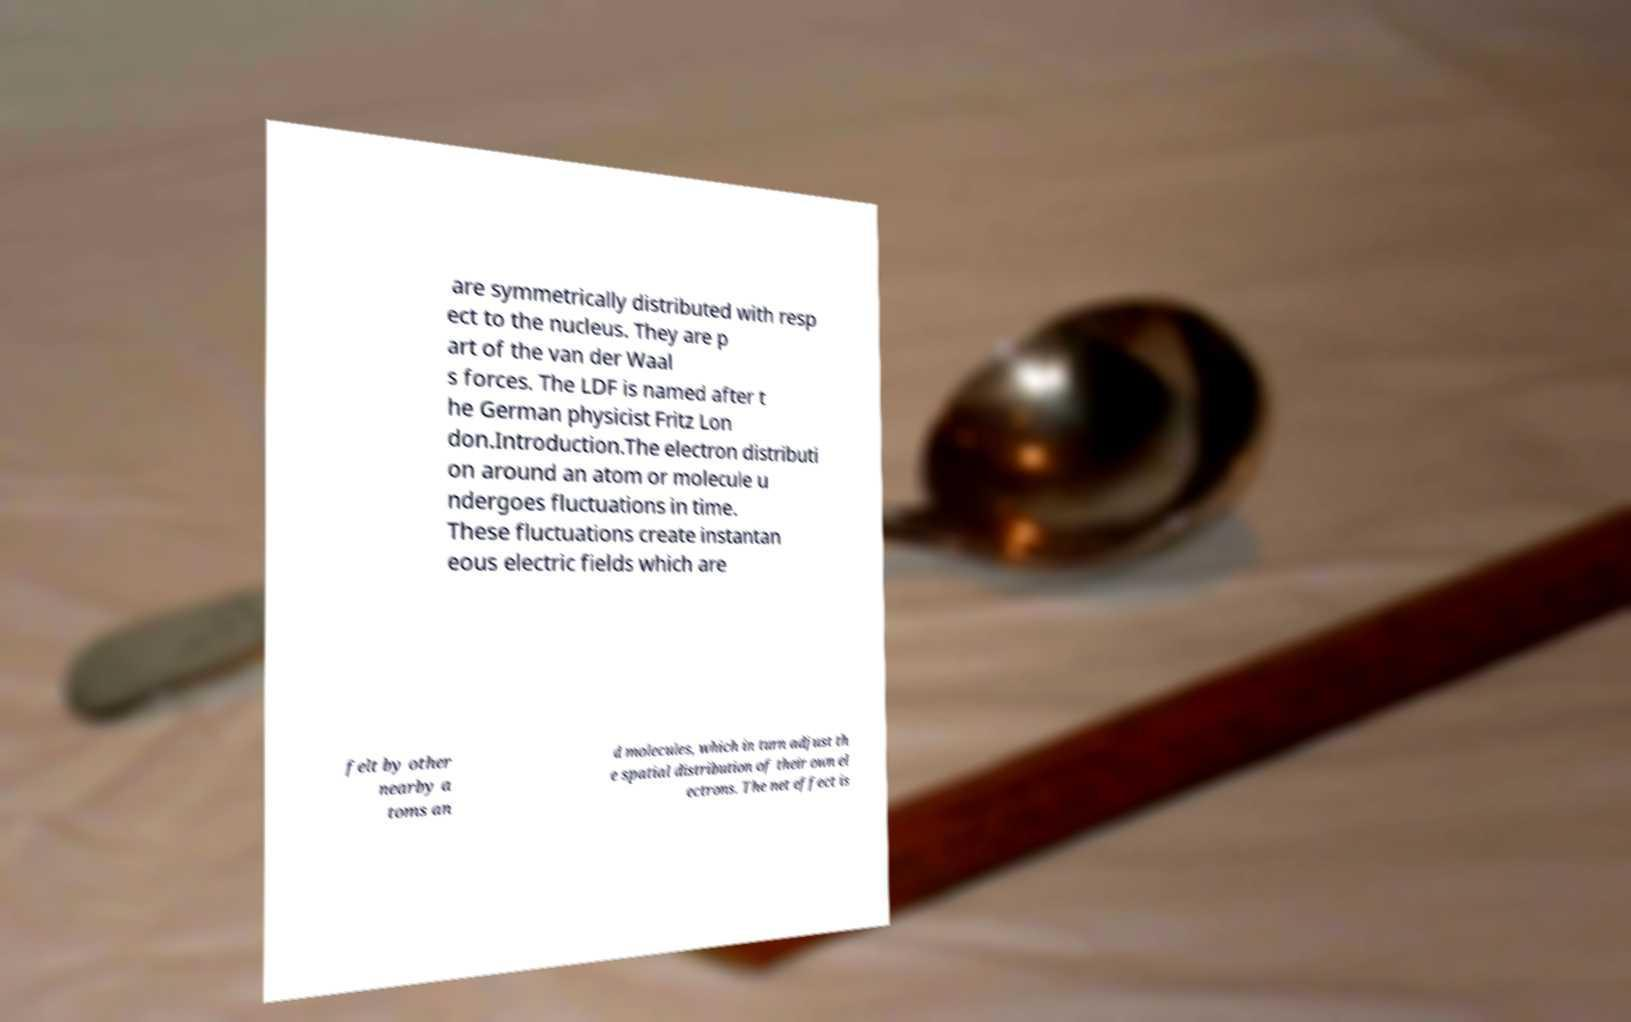What messages or text are displayed in this image? I need them in a readable, typed format. are symmetrically distributed with resp ect to the nucleus. They are p art of the van der Waal s forces. The LDF is named after t he German physicist Fritz Lon don.Introduction.The electron distributi on around an atom or molecule u ndergoes fluctuations in time. These fluctuations create instantan eous electric fields which are felt by other nearby a toms an d molecules, which in turn adjust th e spatial distribution of their own el ectrons. The net effect is 